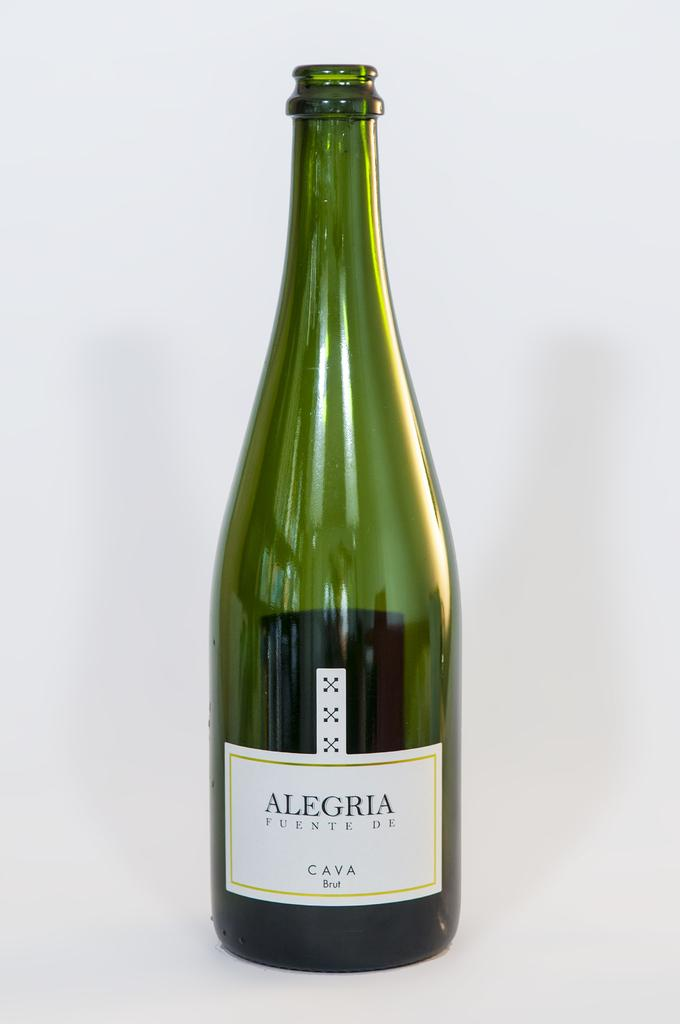What is the color of the bottle in the image? The bottle in the image is green. How is the green color bottle depicted in the image? The green color bottle is highlighted in the image. What type of quartz is visible on the canvas in the image? There is no quartz or canvas present in the image; it only features a green color bottle. 